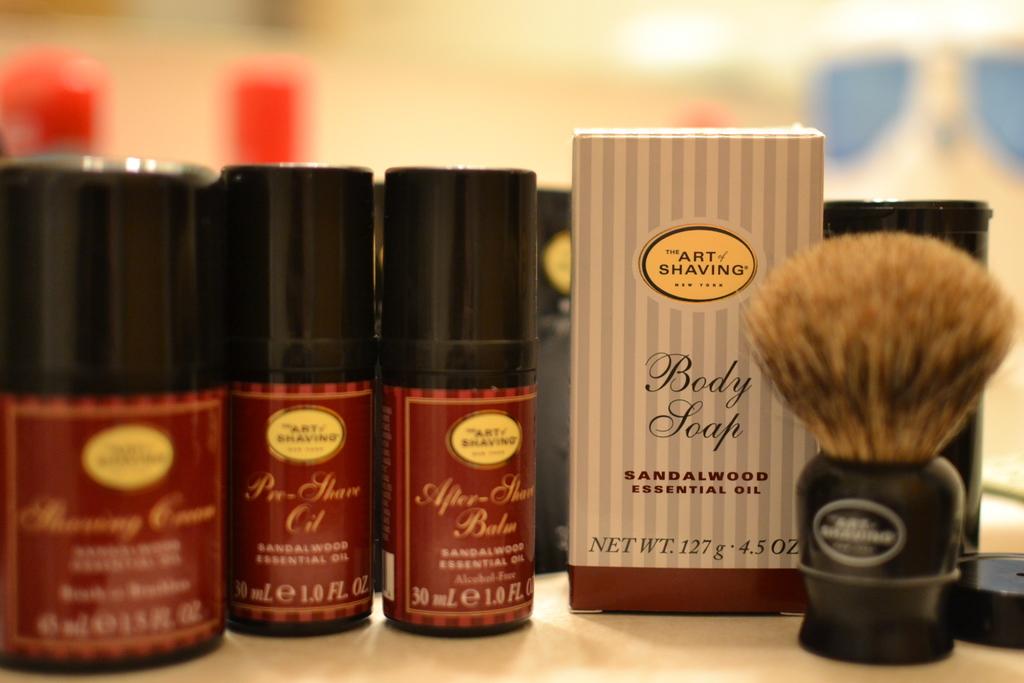How many ounces is this?
Offer a terse response. 4.5. 